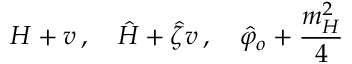<formula> <loc_0><loc_0><loc_500><loc_500>H + v \, , \quad \hat { H } + \hat { \zeta } v \, , \quad \hat { \varphi } _ { o } + { \frac { m _ { H } ^ { 2 } } { 4 } }</formula> 